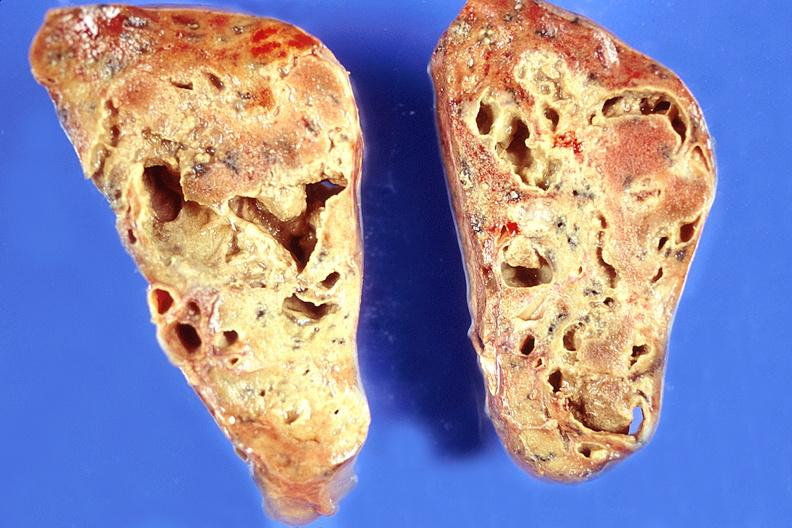what is present?
Answer the question using a single word or phrase. Respiratory 